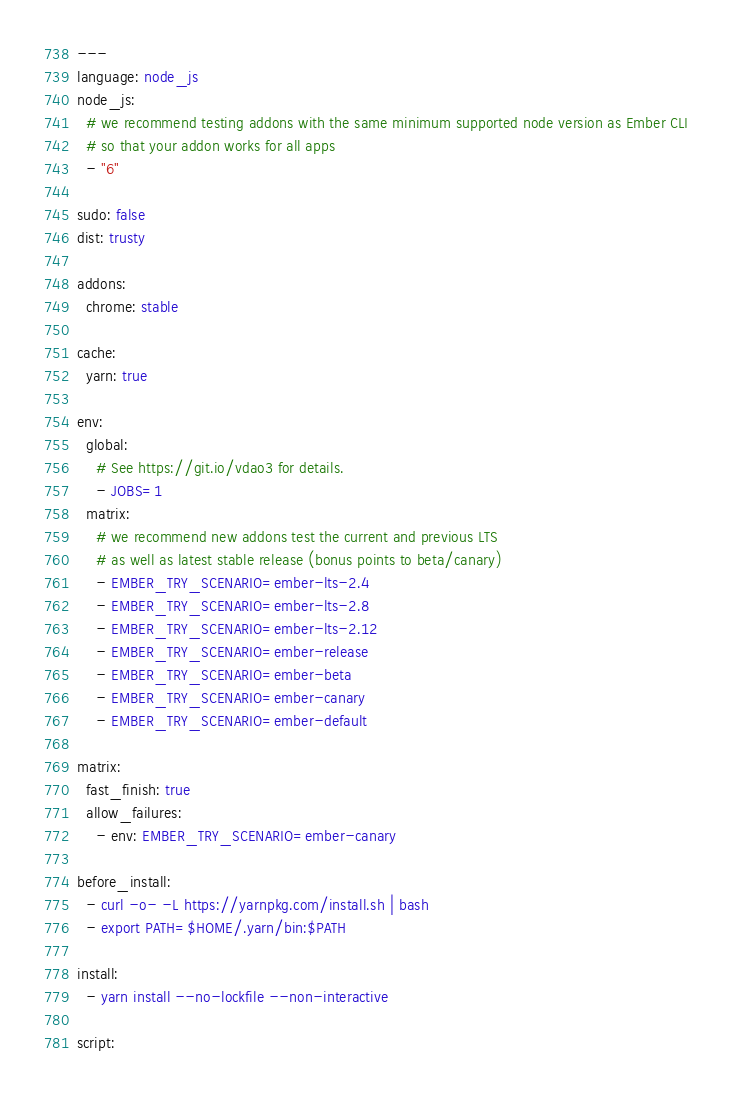<code> <loc_0><loc_0><loc_500><loc_500><_YAML_>---
language: node_js
node_js:
  # we recommend testing addons with the same minimum supported node version as Ember CLI
  # so that your addon works for all apps
  - "6"

sudo: false
dist: trusty

addons:
  chrome: stable

cache:
  yarn: true

env:
  global:
    # See https://git.io/vdao3 for details.
    - JOBS=1
  matrix:
    # we recommend new addons test the current and previous LTS
    # as well as latest stable release (bonus points to beta/canary)
    - EMBER_TRY_SCENARIO=ember-lts-2.4
    - EMBER_TRY_SCENARIO=ember-lts-2.8
    - EMBER_TRY_SCENARIO=ember-lts-2.12
    - EMBER_TRY_SCENARIO=ember-release
    - EMBER_TRY_SCENARIO=ember-beta
    - EMBER_TRY_SCENARIO=ember-canary
    - EMBER_TRY_SCENARIO=ember-default

matrix:
  fast_finish: true
  allow_failures:
    - env: EMBER_TRY_SCENARIO=ember-canary

before_install:
  - curl -o- -L https://yarnpkg.com/install.sh | bash
  - export PATH=$HOME/.yarn/bin:$PATH

install:
  - yarn install --no-lockfile --non-interactive

script:</code> 